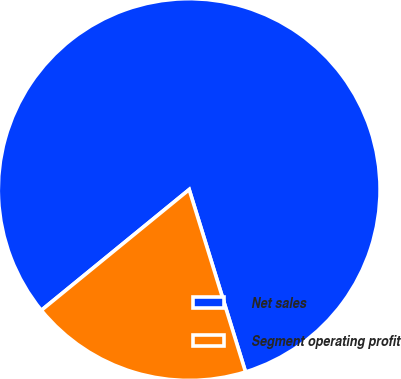<chart> <loc_0><loc_0><loc_500><loc_500><pie_chart><fcel>Net sales<fcel>Segment operating profit<nl><fcel>81.13%<fcel>18.87%<nl></chart> 